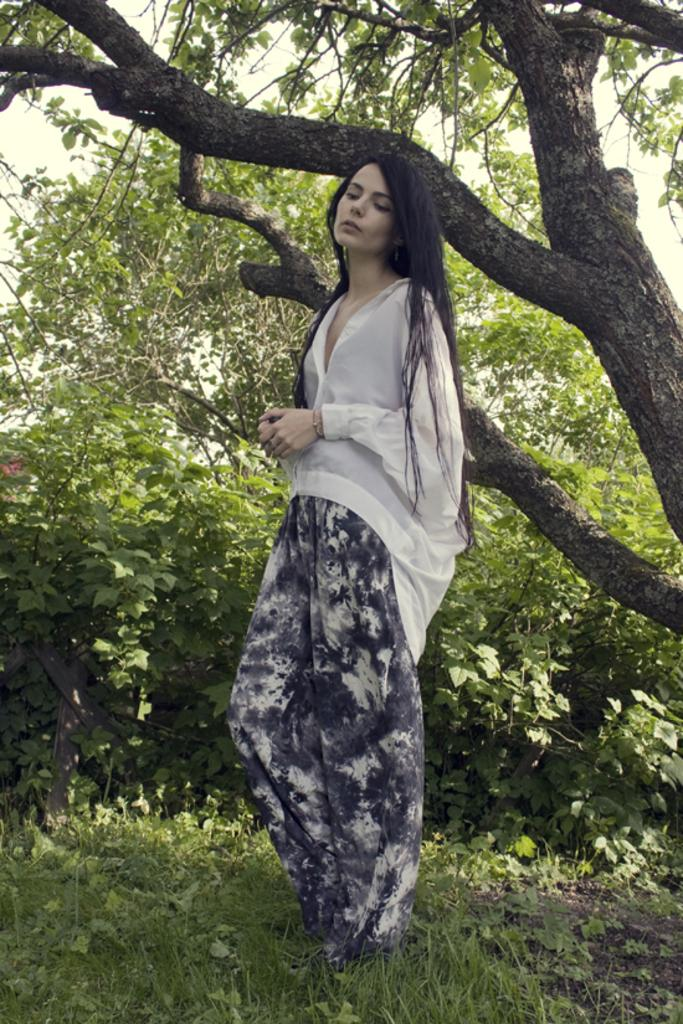What is the main subject of the image? There is a woman standing in the image. Where is the woman standing? The woman is standing on the grass. What can be seen in the background of the image? There are plants, trees, and the sky visible in the background of the image. What type of process is the woman performing with the hose in the image? There is no hose present in the image, so no process involving a hose can be observed. 